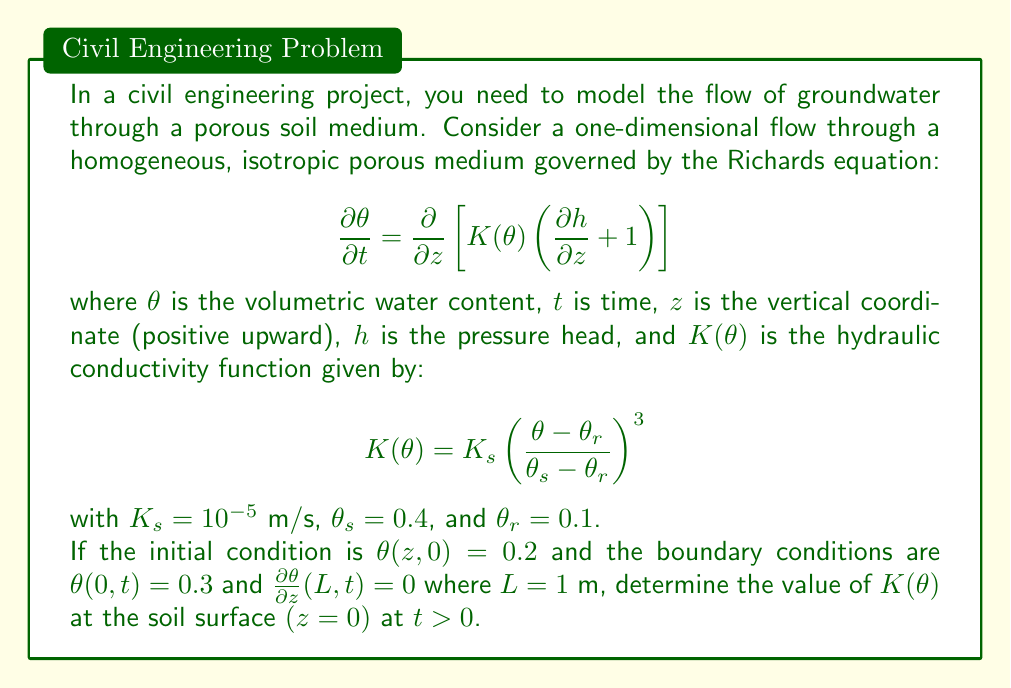What is the answer to this math problem? To solve this problem, we'll follow these steps:

1) First, we need to calculate the value of $\theta$ at the soil surface $(z=0)$. From the boundary condition, we know that $\theta(0,t) = 0.3$ for $t > 0$.

2) Now, we can use this value in the hydraulic conductivity function:

   $$K(\theta) = K_s \left(\frac{\theta - \theta_r}{\theta_s - \theta_r}\right)^3$$

3) Let's substitute the known values:
   $K_s = 10^{-5}$ m/s
   $\theta = 0.3$ (at $z=0$, $t>0$)
   $\theta_s = 0.4$
   $\theta_r = 0.1$

4) Now we can calculate:

   $$K(0.3) = 10^{-5} \left(\frac{0.3 - 0.1}{0.4 - 0.1}\right)^3$$

5) Simplify:
   $$K(0.3) = 10^{-5} \left(\frac{0.2}{0.3}\right)^3$$

6) Calculate:
   $$K(0.3) = 10^{-5} \cdot (0.667)^3 = 10^{-5} \cdot 0.296 = 2.96 \times 10^{-6}$$ m/s

Therefore, the value of $K(\theta)$ at the soil surface $(z=0)$ at $t > 0$ is approximately $2.96 \times 10^{-6}$ m/s.
Answer: $2.96 \times 10^{-6}$ m/s 